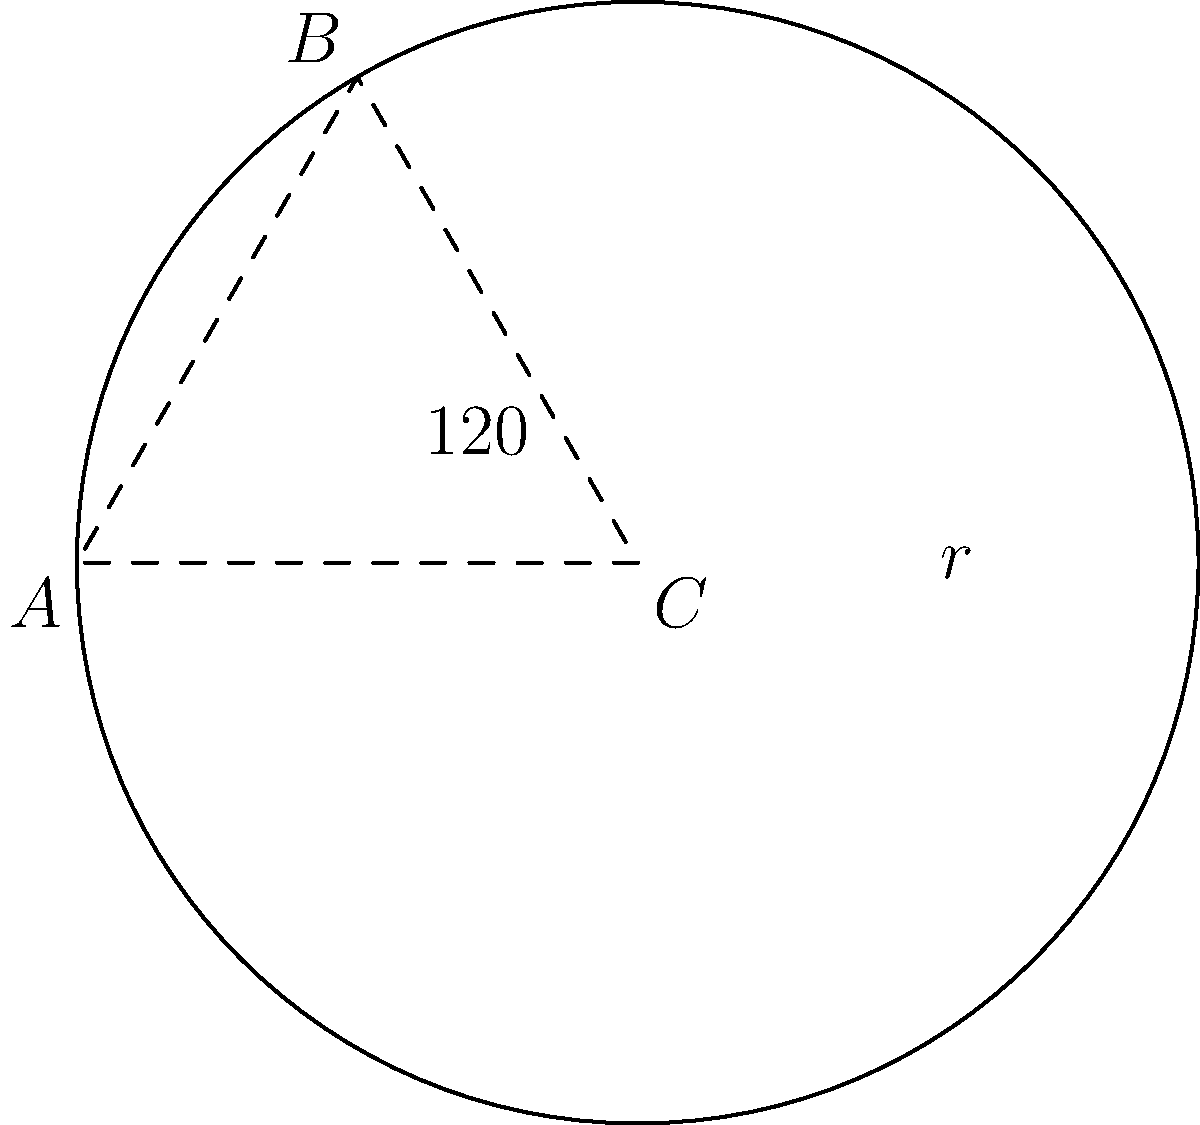A circular wind turbine blade has a radius of 30 meters. If the blade is divided into three equal sectors, and only two of these sectors are coated with a special material that increases efficiency by 25%, what is the total effective area of the blade in square meters? (Assume the uncoated sector has no efficiency gain, and round your answer to the nearest whole number.) Let's approach this step-by-step:

1) First, calculate the total area of the circular blade:
   $A = \pi r^2 = \pi (30)^2 = 2827.43$ m²

2) Each sector represents 1/3 of the circle. Two sectors are coated, so 2/3 of the circle is coated.
   Coated area: $\frac{2}{3} \times 2827.43 = 1884.95$ m²
   Uncoated area: $\frac{1}{3} \times 2827.43 = 942.48$ m²

3) The coated area has a 25% efficiency increase. This means its effective area is 125% of its actual area:
   Effective coated area: $1884.95 \times 1.25 = 2356.19$ m²

4) The uncoated area has no efficiency gain, so its effective area is the same as its actual area:
   Effective uncoated area: $942.48$ m²

5) Total effective area is the sum of effective coated and uncoated areas:
   $2356.19 + 942.48 = 3298.67$ m²

6) Rounding to the nearest whole number: 3299 m²
Answer: 3299 m² 